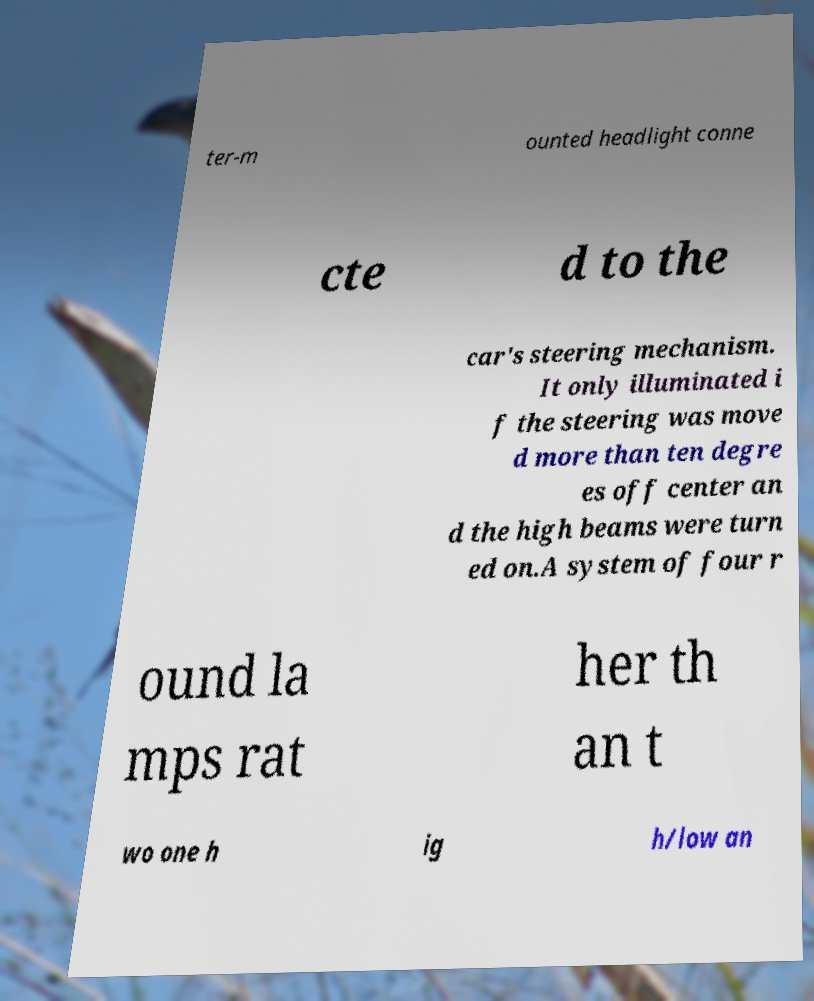Please identify and transcribe the text found in this image. ter-m ounted headlight conne cte d to the car's steering mechanism. It only illuminated i f the steering was move d more than ten degre es off center an d the high beams were turn ed on.A system of four r ound la mps rat her th an t wo one h ig h/low an 